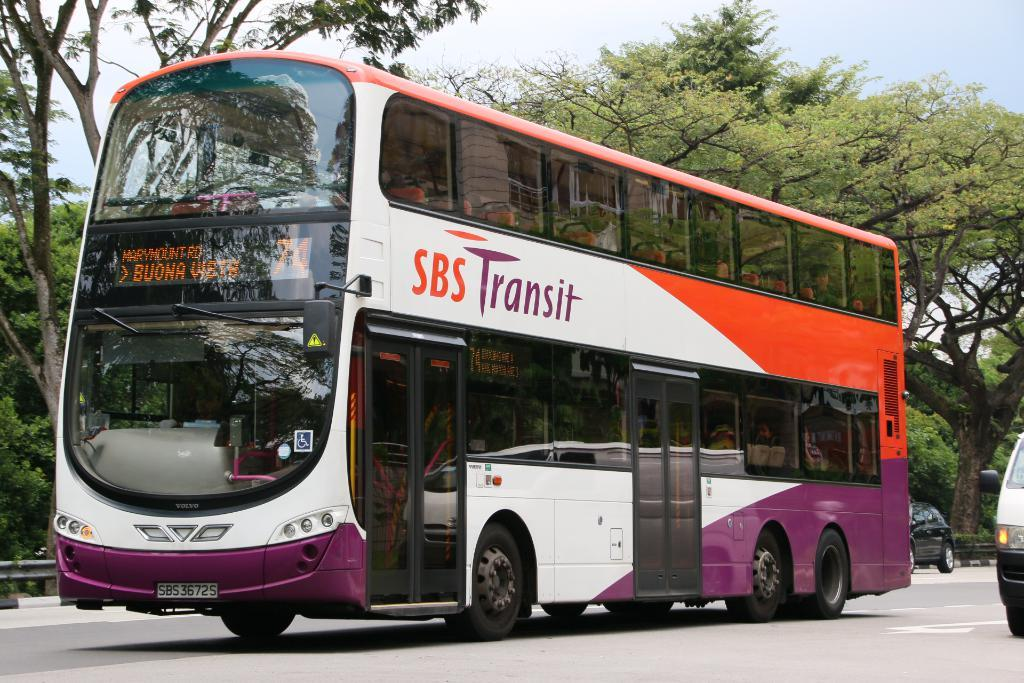What type of vehicle is on the road in the image? There is a bus on the road in the image. How many other vehicles can be seen in the image? There are two cars visible in the image. What can be seen in the background of the image? There are trees in the background of the image. What is visible above the vehicles and trees in the image? The sky is visible in the image. Can you see the friend of the bus driver in the image? There is no indication of a bus driver or any friends in the image; it only shows a bus, two cars, trees, and the sky. 